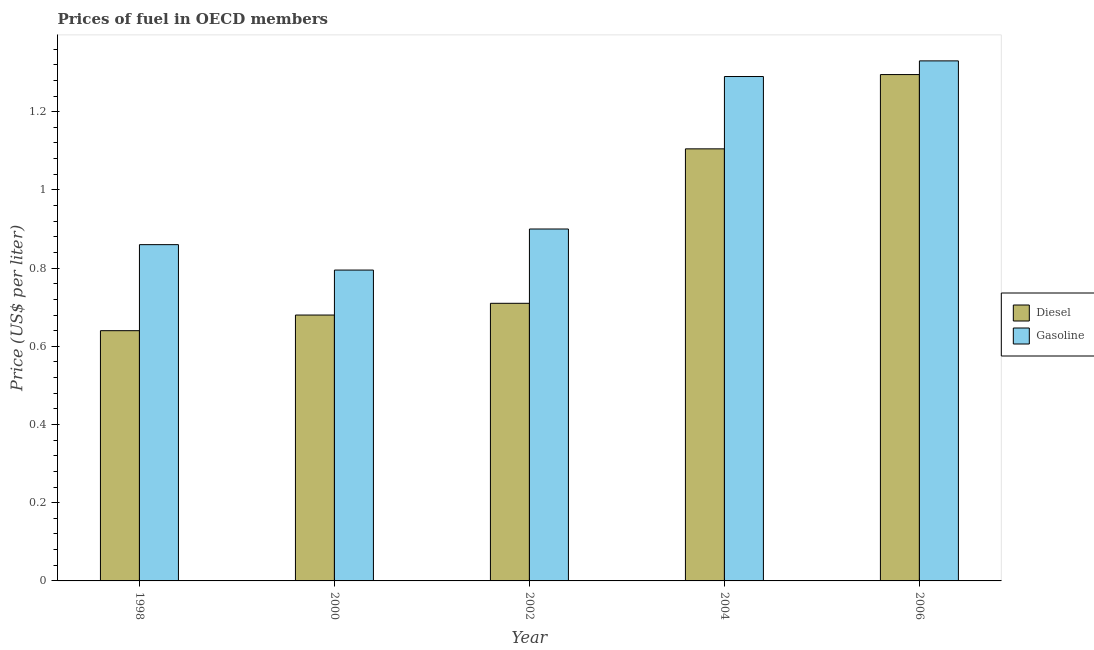Are the number of bars per tick equal to the number of legend labels?
Keep it short and to the point. Yes. How many bars are there on the 5th tick from the left?
Keep it short and to the point. 2. How many bars are there on the 1st tick from the right?
Make the answer very short. 2. What is the label of the 5th group of bars from the left?
Provide a succinct answer. 2006. What is the diesel price in 2004?
Your answer should be compact. 1.1. Across all years, what is the maximum gasoline price?
Your answer should be very brief. 1.33. Across all years, what is the minimum gasoline price?
Keep it short and to the point. 0.8. In which year was the gasoline price maximum?
Your response must be concise. 2006. In which year was the gasoline price minimum?
Your answer should be compact. 2000. What is the total gasoline price in the graph?
Offer a very short reply. 5.18. What is the difference between the gasoline price in 2002 and that in 2004?
Offer a very short reply. -0.39. What is the difference between the diesel price in 2000 and the gasoline price in 2002?
Give a very brief answer. -0.03. What is the average gasoline price per year?
Your answer should be compact. 1.04. In the year 2000, what is the difference between the gasoline price and diesel price?
Keep it short and to the point. 0. In how many years, is the gasoline price greater than 1.2800000000000002 US$ per litre?
Offer a very short reply. 2. What is the ratio of the diesel price in 1998 to that in 2000?
Offer a very short reply. 0.94. Is the diesel price in 1998 less than that in 2004?
Give a very brief answer. Yes. What is the difference between the highest and the second highest gasoline price?
Keep it short and to the point. 0.04. What is the difference between the highest and the lowest diesel price?
Your answer should be very brief. 0.65. What does the 2nd bar from the left in 2006 represents?
Your answer should be very brief. Gasoline. What does the 2nd bar from the right in 2006 represents?
Your answer should be compact. Diesel. How many bars are there?
Provide a short and direct response. 10. How many years are there in the graph?
Your answer should be very brief. 5. Does the graph contain any zero values?
Your answer should be compact. No. Does the graph contain grids?
Your response must be concise. No. Where does the legend appear in the graph?
Your answer should be very brief. Center right. What is the title of the graph?
Provide a succinct answer. Prices of fuel in OECD members. Does "From Government" appear as one of the legend labels in the graph?
Keep it short and to the point. No. What is the label or title of the X-axis?
Your response must be concise. Year. What is the label or title of the Y-axis?
Your answer should be very brief. Price (US$ per liter). What is the Price (US$ per liter) of Diesel in 1998?
Make the answer very short. 0.64. What is the Price (US$ per liter) of Gasoline in 1998?
Give a very brief answer. 0.86. What is the Price (US$ per liter) in Diesel in 2000?
Your answer should be compact. 0.68. What is the Price (US$ per liter) in Gasoline in 2000?
Provide a succinct answer. 0.8. What is the Price (US$ per liter) of Diesel in 2002?
Your response must be concise. 0.71. What is the Price (US$ per liter) in Diesel in 2004?
Your response must be concise. 1.1. What is the Price (US$ per liter) in Gasoline in 2004?
Your answer should be very brief. 1.29. What is the Price (US$ per liter) of Diesel in 2006?
Offer a very short reply. 1.29. What is the Price (US$ per liter) in Gasoline in 2006?
Offer a terse response. 1.33. Across all years, what is the maximum Price (US$ per liter) in Diesel?
Your answer should be compact. 1.29. Across all years, what is the maximum Price (US$ per liter) of Gasoline?
Provide a succinct answer. 1.33. Across all years, what is the minimum Price (US$ per liter) of Diesel?
Make the answer very short. 0.64. Across all years, what is the minimum Price (US$ per liter) in Gasoline?
Provide a succinct answer. 0.8. What is the total Price (US$ per liter) of Diesel in the graph?
Give a very brief answer. 4.43. What is the total Price (US$ per liter) of Gasoline in the graph?
Keep it short and to the point. 5.17. What is the difference between the Price (US$ per liter) of Diesel in 1998 and that in 2000?
Provide a succinct answer. -0.04. What is the difference between the Price (US$ per liter) of Gasoline in 1998 and that in 2000?
Keep it short and to the point. 0.07. What is the difference between the Price (US$ per liter) of Diesel in 1998 and that in 2002?
Your answer should be compact. -0.07. What is the difference between the Price (US$ per liter) of Gasoline in 1998 and that in 2002?
Provide a succinct answer. -0.04. What is the difference between the Price (US$ per liter) in Diesel in 1998 and that in 2004?
Provide a short and direct response. -0.47. What is the difference between the Price (US$ per liter) of Gasoline in 1998 and that in 2004?
Give a very brief answer. -0.43. What is the difference between the Price (US$ per liter) of Diesel in 1998 and that in 2006?
Make the answer very short. -0.66. What is the difference between the Price (US$ per liter) in Gasoline in 1998 and that in 2006?
Ensure brevity in your answer.  -0.47. What is the difference between the Price (US$ per liter) of Diesel in 2000 and that in 2002?
Offer a very short reply. -0.03. What is the difference between the Price (US$ per liter) in Gasoline in 2000 and that in 2002?
Your answer should be compact. -0.1. What is the difference between the Price (US$ per liter) in Diesel in 2000 and that in 2004?
Your answer should be compact. -0.42. What is the difference between the Price (US$ per liter) in Gasoline in 2000 and that in 2004?
Your answer should be very brief. -0.49. What is the difference between the Price (US$ per liter) of Diesel in 2000 and that in 2006?
Offer a very short reply. -0.61. What is the difference between the Price (US$ per liter) in Gasoline in 2000 and that in 2006?
Give a very brief answer. -0.54. What is the difference between the Price (US$ per liter) in Diesel in 2002 and that in 2004?
Make the answer very short. -0.4. What is the difference between the Price (US$ per liter) of Gasoline in 2002 and that in 2004?
Your answer should be compact. -0.39. What is the difference between the Price (US$ per liter) of Diesel in 2002 and that in 2006?
Make the answer very short. -0.58. What is the difference between the Price (US$ per liter) in Gasoline in 2002 and that in 2006?
Ensure brevity in your answer.  -0.43. What is the difference between the Price (US$ per liter) in Diesel in 2004 and that in 2006?
Provide a succinct answer. -0.19. What is the difference between the Price (US$ per liter) of Gasoline in 2004 and that in 2006?
Ensure brevity in your answer.  -0.04. What is the difference between the Price (US$ per liter) in Diesel in 1998 and the Price (US$ per liter) in Gasoline in 2000?
Ensure brevity in your answer.  -0.15. What is the difference between the Price (US$ per liter) of Diesel in 1998 and the Price (US$ per liter) of Gasoline in 2002?
Offer a very short reply. -0.26. What is the difference between the Price (US$ per liter) of Diesel in 1998 and the Price (US$ per liter) of Gasoline in 2004?
Make the answer very short. -0.65. What is the difference between the Price (US$ per liter) of Diesel in 1998 and the Price (US$ per liter) of Gasoline in 2006?
Provide a short and direct response. -0.69. What is the difference between the Price (US$ per liter) in Diesel in 2000 and the Price (US$ per liter) in Gasoline in 2002?
Give a very brief answer. -0.22. What is the difference between the Price (US$ per liter) in Diesel in 2000 and the Price (US$ per liter) in Gasoline in 2004?
Provide a short and direct response. -0.61. What is the difference between the Price (US$ per liter) of Diesel in 2000 and the Price (US$ per liter) of Gasoline in 2006?
Your answer should be very brief. -0.65. What is the difference between the Price (US$ per liter) of Diesel in 2002 and the Price (US$ per liter) of Gasoline in 2004?
Provide a short and direct response. -0.58. What is the difference between the Price (US$ per liter) of Diesel in 2002 and the Price (US$ per liter) of Gasoline in 2006?
Your answer should be compact. -0.62. What is the difference between the Price (US$ per liter) in Diesel in 2004 and the Price (US$ per liter) in Gasoline in 2006?
Offer a terse response. -0.23. What is the average Price (US$ per liter) of Diesel per year?
Your response must be concise. 0.89. What is the average Price (US$ per liter) of Gasoline per year?
Provide a short and direct response. 1.03. In the year 1998, what is the difference between the Price (US$ per liter) of Diesel and Price (US$ per liter) of Gasoline?
Keep it short and to the point. -0.22. In the year 2000, what is the difference between the Price (US$ per liter) in Diesel and Price (US$ per liter) in Gasoline?
Give a very brief answer. -0.12. In the year 2002, what is the difference between the Price (US$ per liter) of Diesel and Price (US$ per liter) of Gasoline?
Keep it short and to the point. -0.19. In the year 2004, what is the difference between the Price (US$ per liter) of Diesel and Price (US$ per liter) of Gasoline?
Provide a succinct answer. -0.18. In the year 2006, what is the difference between the Price (US$ per liter) of Diesel and Price (US$ per liter) of Gasoline?
Ensure brevity in your answer.  -0.04. What is the ratio of the Price (US$ per liter) in Gasoline in 1998 to that in 2000?
Give a very brief answer. 1.08. What is the ratio of the Price (US$ per liter) of Diesel in 1998 to that in 2002?
Make the answer very short. 0.9. What is the ratio of the Price (US$ per liter) in Gasoline in 1998 to that in 2002?
Keep it short and to the point. 0.96. What is the ratio of the Price (US$ per liter) in Diesel in 1998 to that in 2004?
Offer a very short reply. 0.58. What is the ratio of the Price (US$ per liter) in Gasoline in 1998 to that in 2004?
Provide a succinct answer. 0.67. What is the ratio of the Price (US$ per liter) in Diesel in 1998 to that in 2006?
Ensure brevity in your answer.  0.49. What is the ratio of the Price (US$ per liter) in Gasoline in 1998 to that in 2006?
Make the answer very short. 0.65. What is the ratio of the Price (US$ per liter) of Diesel in 2000 to that in 2002?
Your answer should be compact. 0.96. What is the ratio of the Price (US$ per liter) in Gasoline in 2000 to that in 2002?
Provide a succinct answer. 0.88. What is the ratio of the Price (US$ per liter) of Diesel in 2000 to that in 2004?
Your answer should be very brief. 0.62. What is the ratio of the Price (US$ per liter) of Gasoline in 2000 to that in 2004?
Your response must be concise. 0.62. What is the ratio of the Price (US$ per liter) in Diesel in 2000 to that in 2006?
Ensure brevity in your answer.  0.53. What is the ratio of the Price (US$ per liter) in Gasoline in 2000 to that in 2006?
Make the answer very short. 0.6. What is the ratio of the Price (US$ per liter) of Diesel in 2002 to that in 2004?
Provide a short and direct response. 0.64. What is the ratio of the Price (US$ per liter) of Gasoline in 2002 to that in 2004?
Your answer should be very brief. 0.7. What is the ratio of the Price (US$ per liter) of Diesel in 2002 to that in 2006?
Your answer should be compact. 0.55. What is the ratio of the Price (US$ per liter) of Gasoline in 2002 to that in 2006?
Your answer should be very brief. 0.68. What is the ratio of the Price (US$ per liter) of Diesel in 2004 to that in 2006?
Keep it short and to the point. 0.85. What is the ratio of the Price (US$ per liter) of Gasoline in 2004 to that in 2006?
Your answer should be compact. 0.97. What is the difference between the highest and the second highest Price (US$ per liter) in Diesel?
Your answer should be very brief. 0.19. What is the difference between the highest and the lowest Price (US$ per liter) in Diesel?
Your response must be concise. 0.66. What is the difference between the highest and the lowest Price (US$ per liter) in Gasoline?
Give a very brief answer. 0.54. 